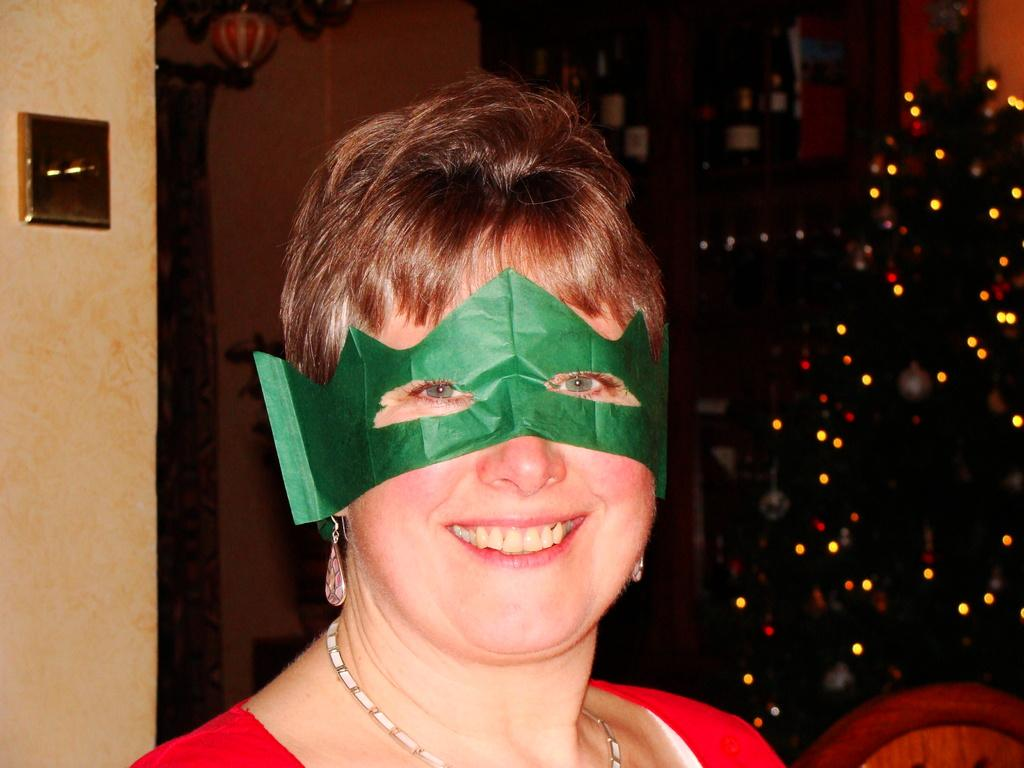Who is present in the image? There is a woman in the image. What is the woman's facial expression? The woman is smiling. What type of jewelry is the woman wearing? The woman is wearing earrings and a necklace. What is covering the woman's face in the image? The woman is wearing a mask. What can be seen in the background of the image? There are lights, a wall, and other objects in the background of the image. What is the woman's brother doing in the image? There is no mention of a brother in the image or the provided facts, so it cannot be determined what the brother might be doing. 